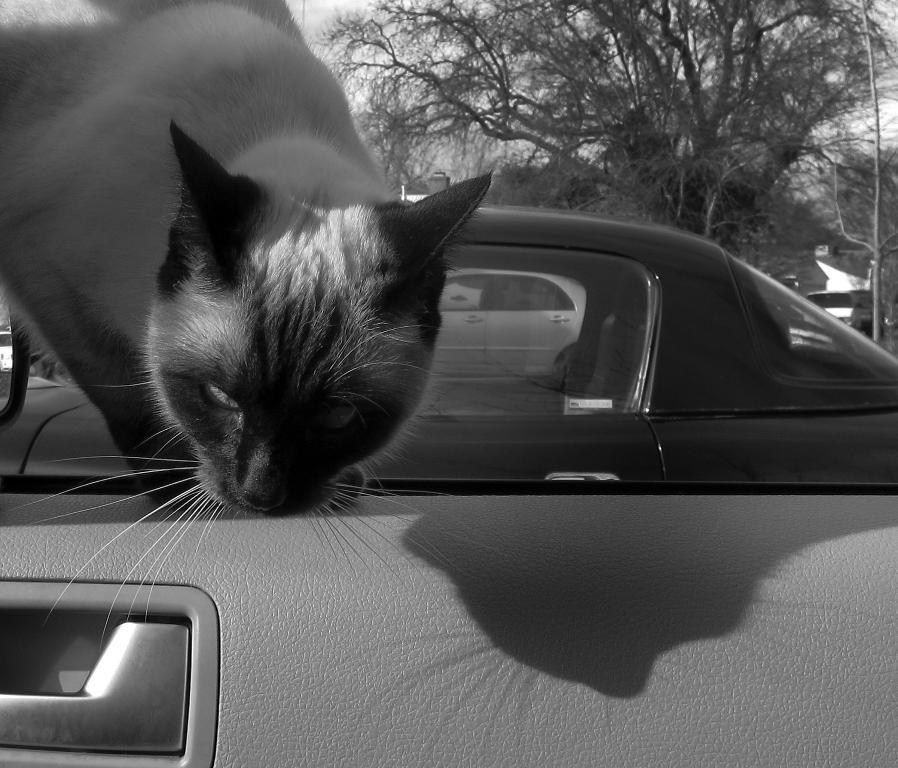What animal can be seen inside the car in the image? There is a cat inside the car in the image. What color is the car at the back? The car at the back is black. What type of vegetation is present in the image? There is a tree in the image. What is visible at the top of the image? The sky is visible at the top of the image. What type of noise can be heard coming from the tree in the image? There is no indication of any noise in the image, as it only shows a cat inside a car, a black car at the back, a tree, and the sky. Does the existence of the tree in the image prove the existence of a parallel universe? The presence of a tree in the image does not provide any information about the existence of a parallel universe; it is simply a tree in the image. 